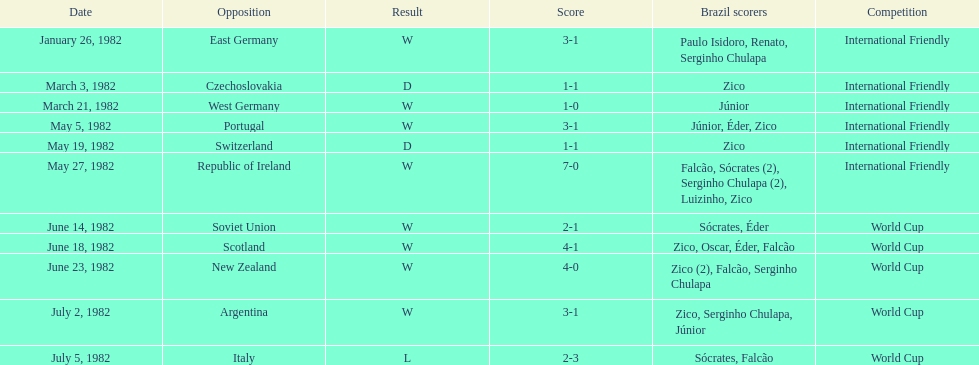Who won on january 26, 1982 and may 27, 1982? Brazil. 